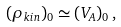Convert formula to latex. <formula><loc_0><loc_0><loc_500><loc_500>( \rho _ { k i n } ) _ { 0 } \simeq ( V _ { A } ) _ { 0 } \, ,</formula> 